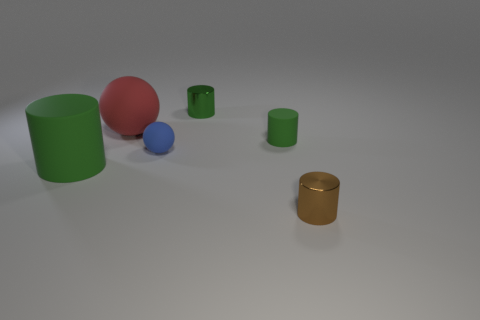Is the tiny brown cylinder made of the same material as the big cylinder that is to the left of the blue rubber ball?
Your answer should be very brief. No. Are there more tiny objects than small rubber balls?
Your response must be concise. Yes. How many spheres are either small purple things or blue rubber things?
Offer a terse response. 1. The big sphere is what color?
Provide a succinct answer. Red. There is a green rubber cylinder that is on the right side of the big red matte thing; does it have the same size as the thing that is behind the red matte ball?
Your answer should be very brief. Yes. Is the number of large yellow rubber objects less than the number of green shiny cylinders?
Ensure brevity in your answer.  Yes. There is a big green matte thing; what number of big green cylinders are left of it?
Make the answer very short. 0. What is the tiny blue object made of?
Give a very brief answer. Rubber. Is the tiny ball the same color as the large sphere?
Ensure brevity in your answer.  No. Are there fewer objects in front of the big red matte sphere than tiny green metal cylinders?
Keep it short and to the point. No. 